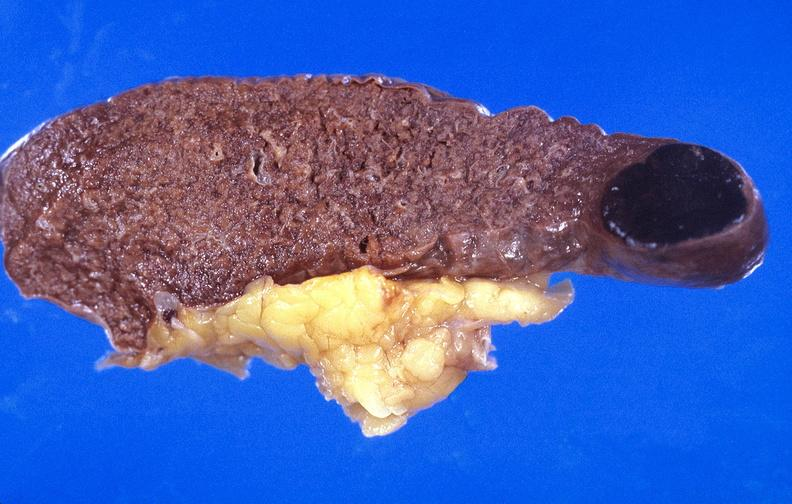where is this part in?
Answer the question using a single word or phrase. Spleen 